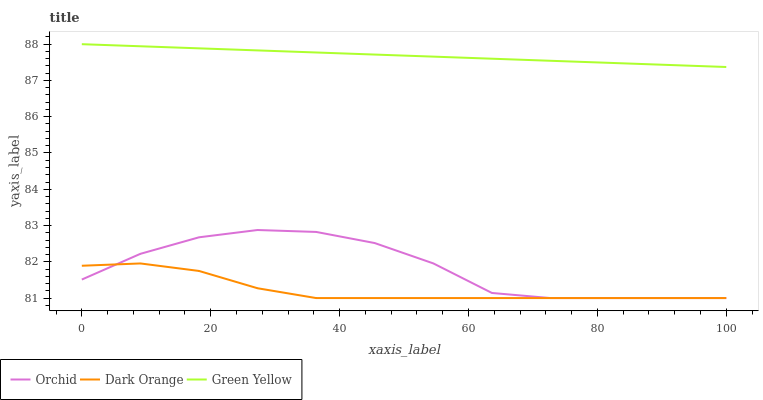Does Dark Orange have the minimum area under the curve?
Answer yes or no. Yes. Does Green Yellow have the maximum area under the curve?
Answer yes or no. Yes. Does Orchid have the minimum area under the curve?
Answer yes or no. No. Does Orchid have the maximum area under the curve?
Answer yes or no. No. Is Green Yellow the smoothest?
Answer yes or no. Yes. Is Orchid the roughest?
Answer yes or no. Yes. Is Orchid the smoothest?
Answer yes or no. No. Is Green Yellow the roughest?
Answer yes or no. No. Does Dark Orange have the lowest value?
Answer yes or no. Yes. Does Green Yellow have the lowest value?
Answer yes or no. No. Does Green Yellow have the highest value?
Answer yes or no. Yes. Does Orchid have the highest value?
Answer yes or no. No. Is Dark Orange less than Green Yellow?
Answer yes or no. Yes. Is Green Yellow greater than Dark Orange?
Answer yes or no. Yes. Does Dark Orange intersect Orchid?
Answer yes or no. Yes. Is Dark Orange less than Orchid?
Answer yes or no. No. Is Dark Orange greater than Orchid?
Answer yes or no. No. Does Dark Orange intersect Green Yellow?
Answer yes or no. No. 